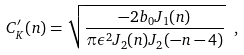Convert formula to latex. <formula><loc_0><loc_0><loc_500><loc_500>C ^ { \prime } _ { K } ( n ) = \sqrt { \frac { - 2 b _ { 0 } J _ { 1 } ( n ) } { \pi \epsilon ^ { 2 } J _ { 2 } ( n ) J _ { 2 } ( - n - 4 ) } } \ ,</formula> 